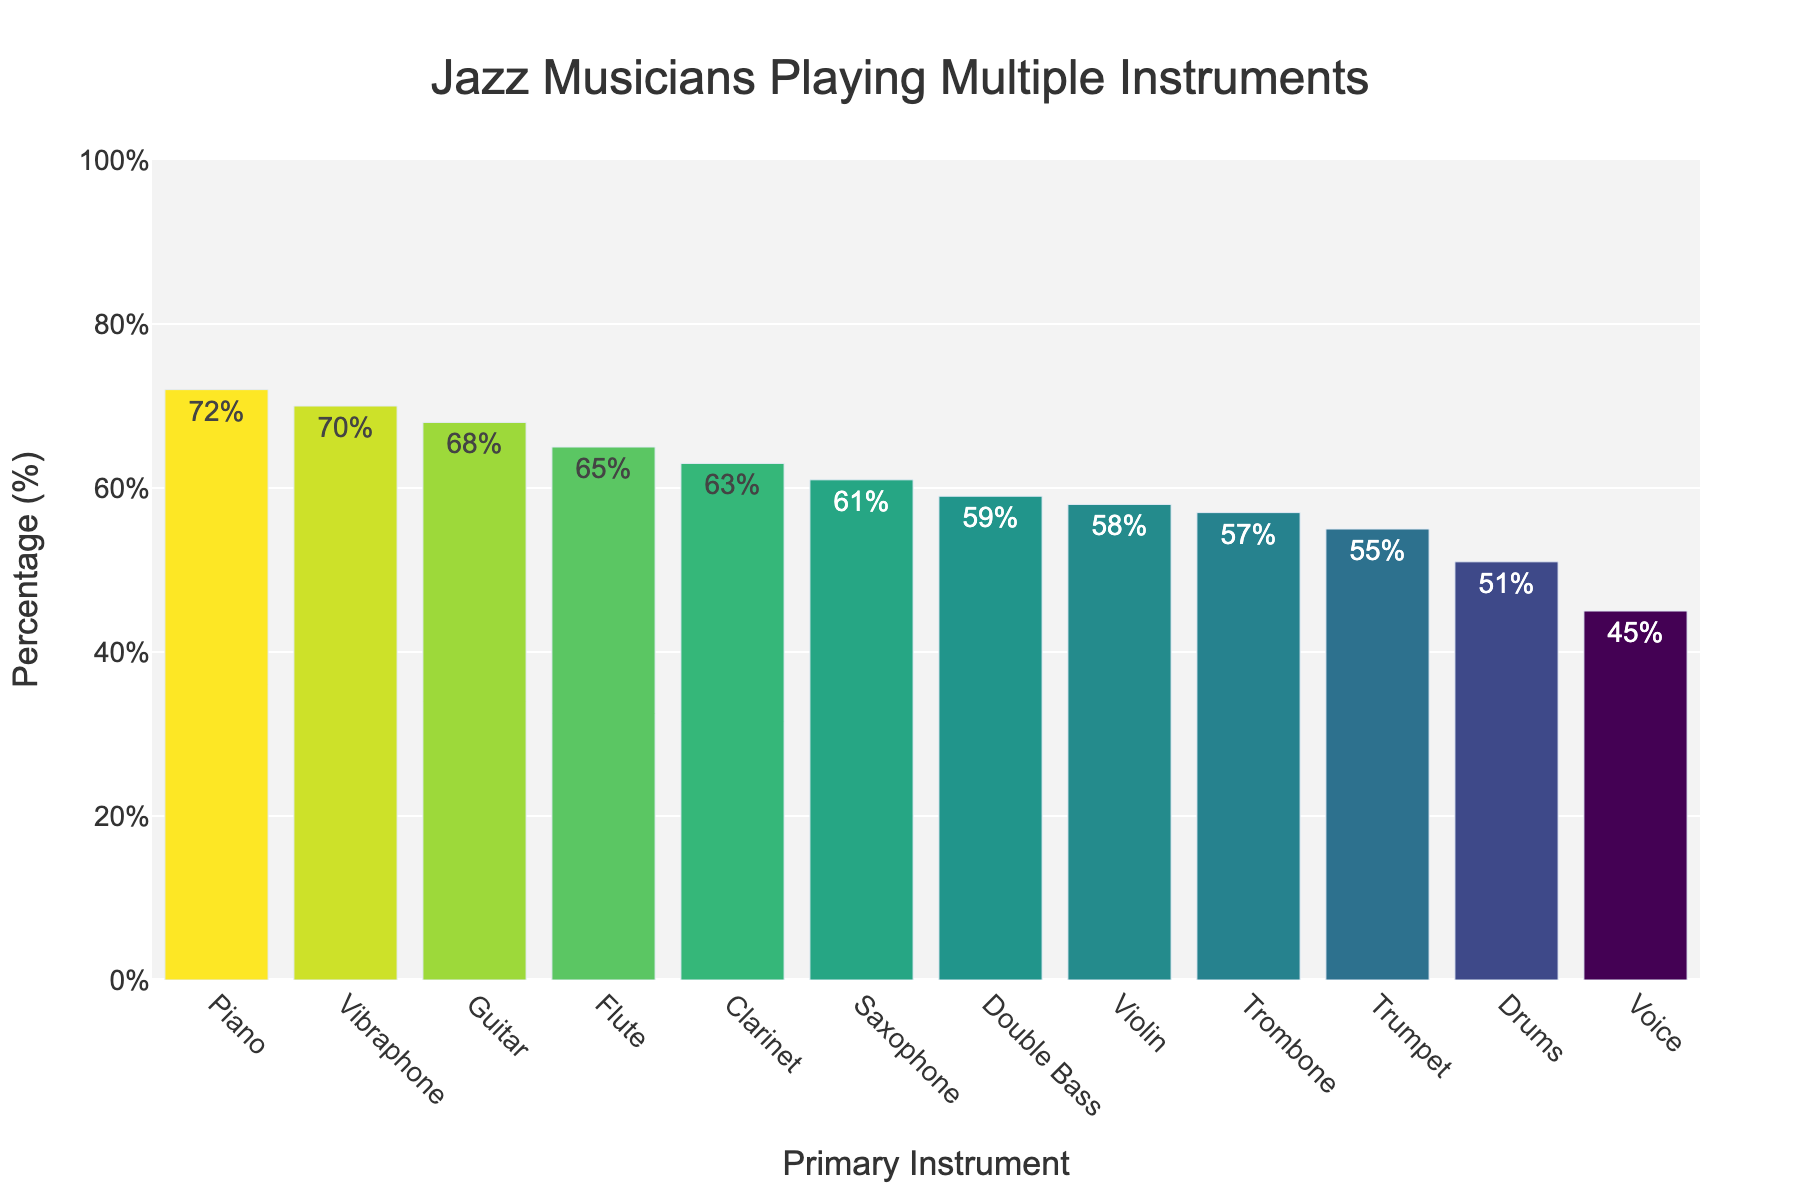What primary instrument has the highest percentage of jazz musicians who play multiple instruments? The figure shows the percentage of musicians who play multiple instruments for each primary instrument. The highest bar represents the primary instrument with the highest percentage, which is the Piano with 72%.
Answer: Piano Which primary instrument has the lowest percentage of multiple instrument players? By looking at the figure, the shortest bar represents the primary instrument with the lowest percentage, which is the Voice with 45%.
Answer: Voice How does the percentage of guitarists who play multiple instruments compare to that of pianists? The percentage of guitarists is 68% and for pianists, it is 72%. By comparing these two values, pianists have a higher percentage than guitarists.
Answer: Pianists have a higher percentage What is the difference in percentage between saxophonists and trumpeters who play multiple instruments? The figure indicates saxophonists at 61% and trumpeters at 55%. The difference is 61% - 55% = 6%.
Answer: 6% What is the combined percentage of clarinet and flute players who play multiple instruments? From the figure, clarinet players are at 63% and flute players are at 65%. The combined percentage is 63% + 65% = 128%.
Answer: 128% Among the given instruments, which three have the closest percentages of musicians who play multiple instruments? By examining the figure, identify the instruments with percentages that are numerically closest: Trombone (57%), Double Bass (59%), and Violin (58%) are close.
Answer: Trombone, Double Bass, Violin What is the median percentage of musicians who play multiple instruments? List the percentages: 45%, 51%, 55%, 57%, 58%, 59%, 61%, 63%, 65%, 68%, 70%, 72%. Ordering them identifies the median as the average of the 6th and 7th values (59% + 61%) / 2 = 60%.
Answer: 60% If you combine the percentages of Voice and Drums players, does it exceed the percentage of Piano players? Voice players are at 45% and Drummers at 51%. Their combined percentage is 45% + 51% = 96%, which exceeds that of Piano players at 72%.
Answer: Yes, it exceeds Which two primary instruments have the colors most different from each other visually in the chart? In the bar chart, the visual color is tied to the percentage, where higher values are lighter, and lower values are darker. The Piano (highest) has a lighter color, and the Voice (lowest) has a darker color.
Answer: Piano and Voice What is the average percentage of the bottom five instruments in terms of multiple instrument players? The bottom five instruments are: Voice (45%), Drums (51%), Trumpet (55%), Trombone (57%), and Violin (58%). The average percentage is (45 + 51 + 55 + 57 + 58) / 5 = 53.2%.
Answer: 53.2% 